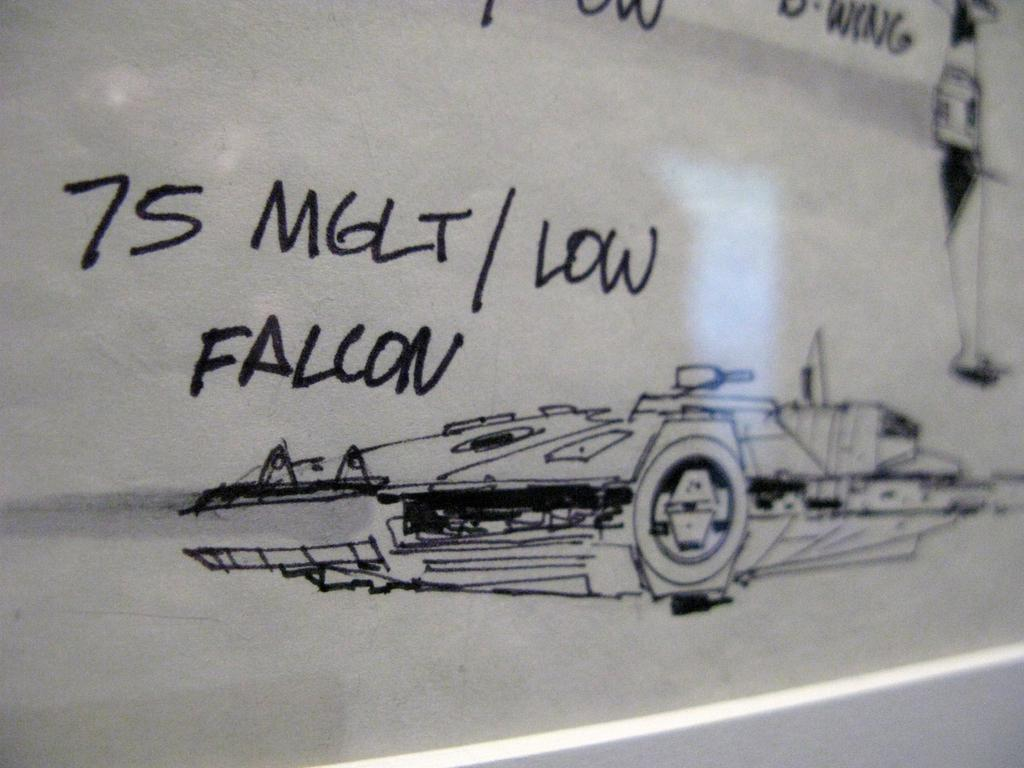What is the main object in the image? There is a white color board in the image. What is on the color board? Something is written on the board with a marker. What color is the wall under the color board? The wall under the color board is white in color. What level of difficulty is the slope in the image? There is no slope present in the image; it only features a white color board with writing on it and a white wall underneath. 